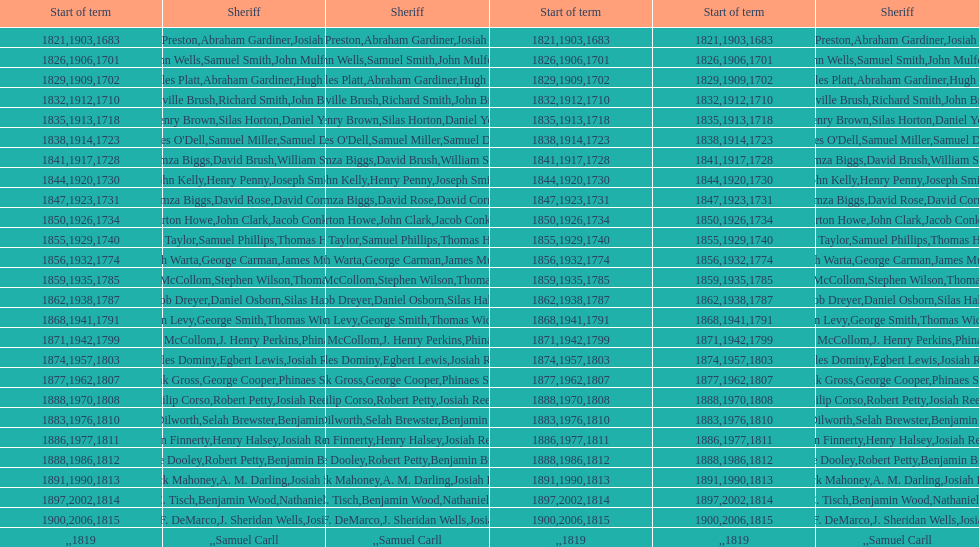Did robert petty serve before josiah reeve? No. 